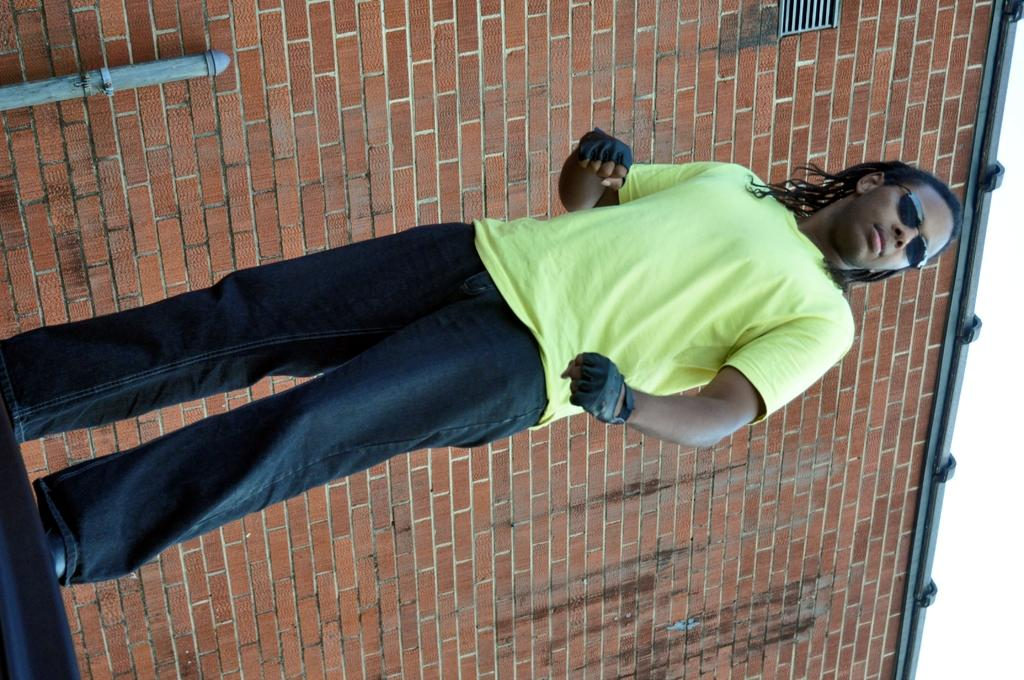What is the main subject of the image? There is a man standing in the image. What can be seen behind the man? There is a wall visible behind the man. How many birds are flying in the image? There are no birds visible in the image. 